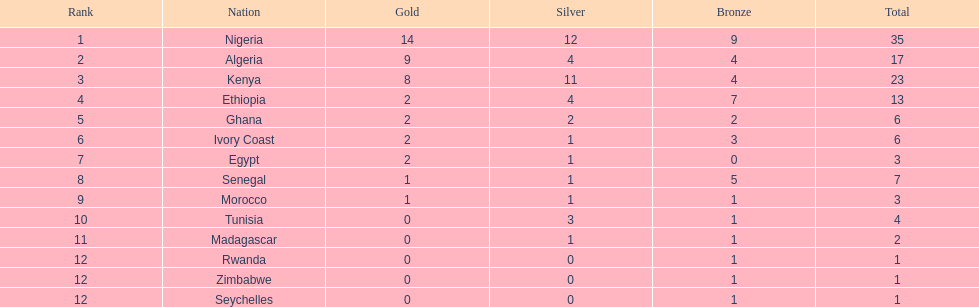The nation above algeria Nigeria. 